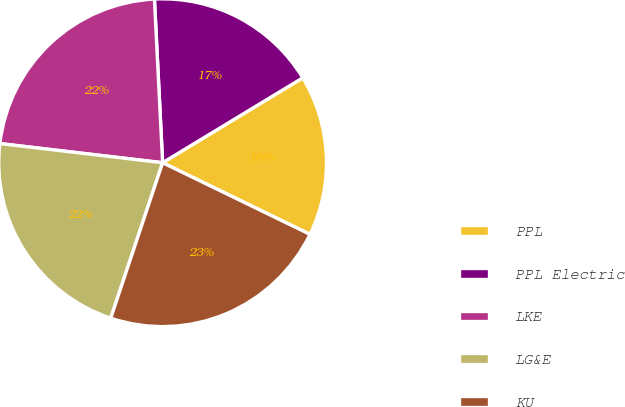Convert chart. <chart><loc_0><loc_0><loc_500><loc_500><pie_chart><fcel>PPL<fcel>PPL Electric<fcel>LKE<fcel>LG&E<fcel>KU<nl><fcel>15.87%<fcel>17.13%<fcel>22.34%<fcel>21.74%<fcel>22.93%<nl></chart> 